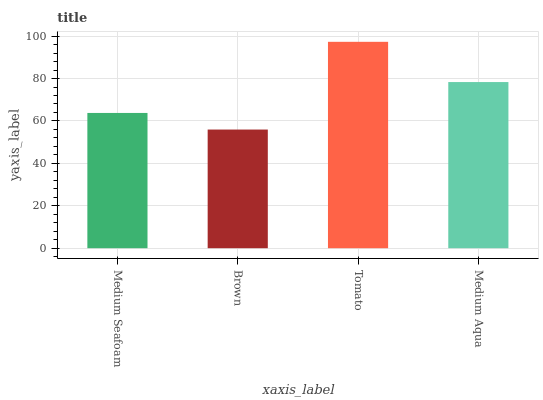Is Brown the minimum?
Answer yes or no. Yes. Is Tomato the maximum?
Answer yes or no. Yes. Is Tomato the minimum?
Answer yes or no. No. Is Brown the maximum?
Answer yes or no. No. Is Tomato greater than Brown?
Answer yes or no. Yes. Is Brown less than Tomato?
Answer yes or no. Yes. Is Brown greater than Tomato?
Answer yes or no. No. Is Tomato less than Brown?
Answer yes or no. No. Is Medium Aqua the high median?
Answer yes or no. Yes. Is Medium Seafoam the low median?
Answer yes or no. Yes. Is Brown the high median?
Answer yes or no. No. Is Brown the low median?
Answer yes or no. No. 